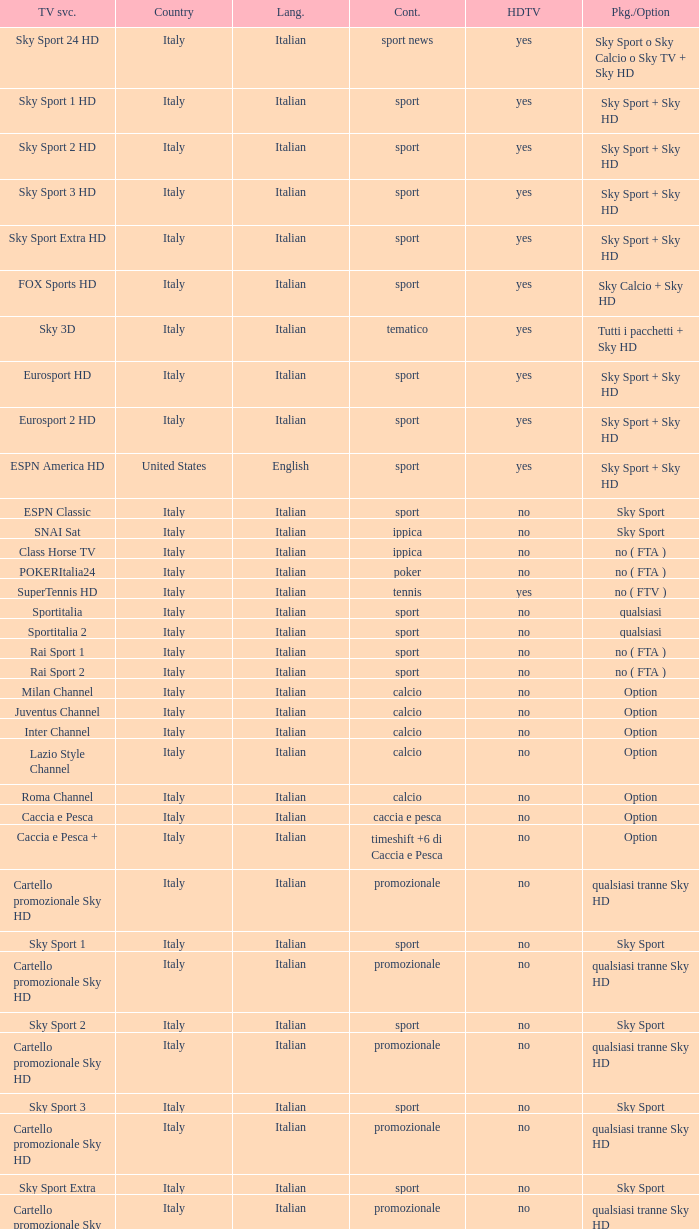What is Package/Option, when Content is Poker? No ( fta ). 